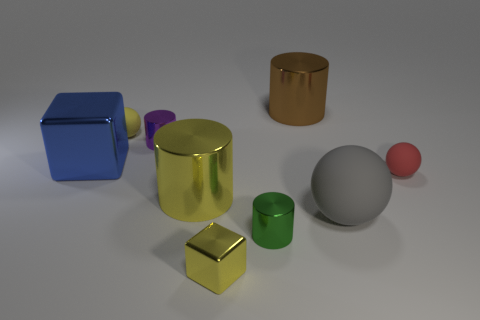Subtract all small spheres. How many spheres are left? 1 Subtract 1 cylinders. How many cylinders are left? 3 Subtract all red cylinders. Subtract all red spheres. How many cylinders are left? 4 Subtract all cubes. How many objects are left? 7 Add 1 big blue objects. How many big blue objects are left? 2 Add 8 small yellow matte balls. How many small yellow matte balls exist? 9 Subtract 0 red cubes. How many objects are left? 9 Subtract all tiny cylinders. Subtract all big gray objects. How many objects are left? 6 